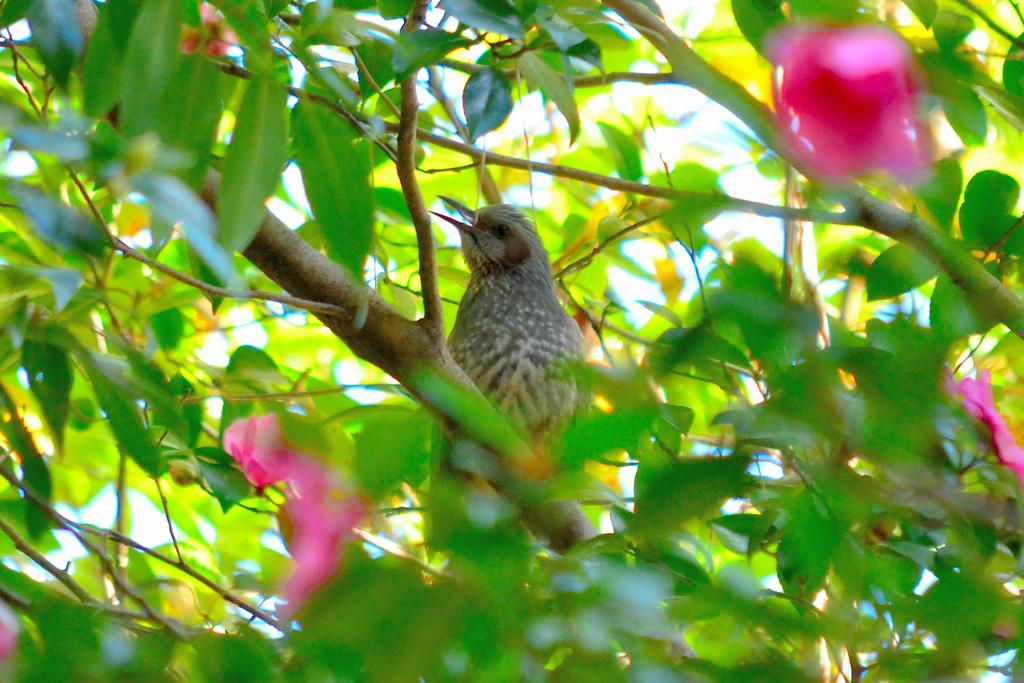What type of animal can be seen in the image? There is a bird in the image. Where is the bird located? The bird is on a tree. What other elements are present in the image? There are flowers in the image. What type of meat is the bird eating in the image? There is no meat present in the image, as the bird is on a tree and not eating anything. 